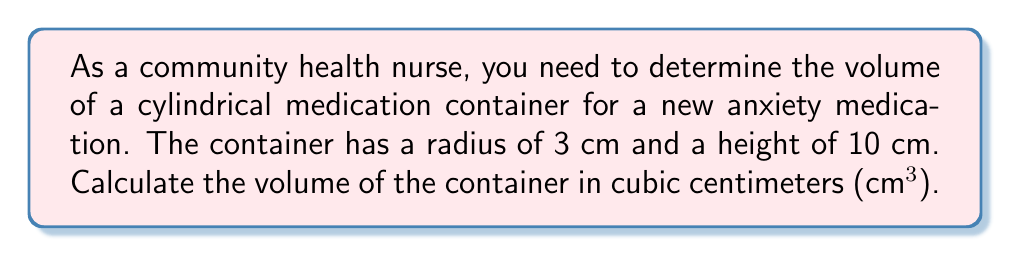Solve this math problem. To calculate the volume of a cylindrical container, we use the formula:

$$V = \pi r^2 h$$

Where:
$V$ = volume
$\pi$ = pi (approximately 3.14159)
$r$ = radius of the base
$h$ = height of the cylinder

Given:
$r = 3$ cm
$h = 10$ cm

Step 1: Substitute the values into the formula:
$$V = \pi (3\text{ cm})^2 (10\text{ cm})$$

Step 2: Calculate the square of the radius:
$$V = \pi (9\text{ cm}^2) (10\text{ cm})$$

Step 3: Multiply the terms:
$$V = 90\pi\text{ cm}^3$$

Step 4: Calculate the final value (rounded to two decimal places):
$$V \approx 282.74\text{ cm}^3$$

[asy]
import geometry;

size(100);
real r = 3;
real h = 10;

draw(circle((0,0),r));
draw((r,0)--(r,h));
draw((-r,0)--(-r,h));
draw(circle((0,h),r));

draw((r,0)--(r,-0.5),Arrow);
draw((0,h)--(0.5,h),Arrow);

label("r",(r/2,-0.7));
label("h",(r+0.7,h/2));
[/asy]
Answer: $282.74\text{ cm}^3$ 